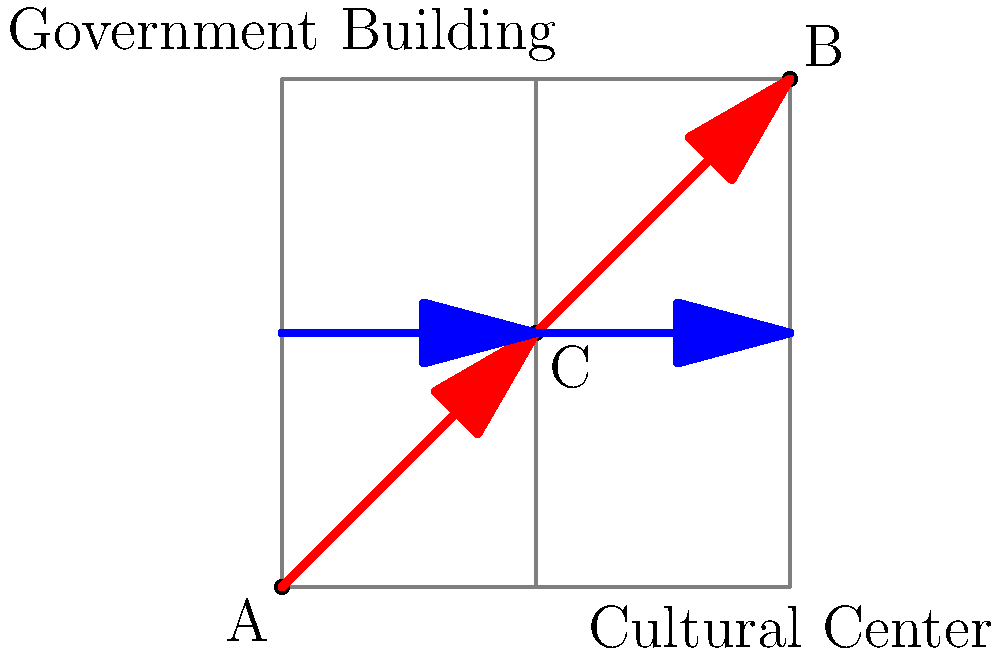In the city map shown, point A represents a cultural center, point B represents a government building, and point C is a central intersection. The red path shows the current main traffic flow, while the blue path indicates a proposed alternative route. Given that the government aims to reduce traffic near its building, which route would you recommend, and how might this decision impact cultural access in a way that aligns with your critique of the local administration? To answer this question, we need to consider several factors:

1. Traffic flow optimization: The current main traffic flow (red path) goes directly from the cultural center (A) to the government building (B), passing through the central intersection (C). This route may cause congestion near the government building.

2. Government's goal: The local government wants to reduce traffic near its building (B), which suggests they prefer the blue path.

3. Cultural access: The blue path maintains a direct route to the cultural center (A) while diverting traffic away from the government building (B).

4. Critical perspective: As a film critic opposing the local government, we should consider how this decision might affect cultural access and potentially reveal the government's priorities.

5. Impact analysis: 
   - The blue path could reduce traffic near the government building, potentially improving its security or privacy.
   - However, this route might also make it more difficult for citizens to approach the government building, which could be seen as a move to distance the administration from the people.
   - The blue path maintains easy access to the cultural center, which is positive for cultural engagement.

6. Critique: From a critical standpoint, we could argue that while the blue path seems to optimize traffic flow and maintain cultural access, it might also serve to isolate the government from its citizens. This could be seen as a metaphor for the government's detachment from the people's needs and concerns.

Given these considerations, the recommended route would be the blue path, as it aligns with traffic optimization goals and maintains cultural access. However, this recommendation comes with a critical observation about the potential motivations and consequences of the government's traffic management decisions.
Answer: Blue path, with critique of government isolation 